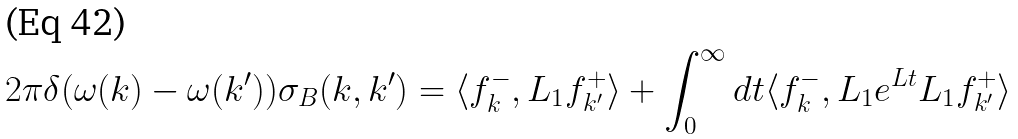<formula> <loc_0><loc_0><loc_500><loc_500>2 \pi \delta ( \omega ( k ) - \omega ( k ^ { \prime } ) ) \sigma _ { B } ( k , k ^ { \prime } ) = \langle f ^ { - } _ { k } , L _ { 1 } f ^ { + } _ { k ^ { \prime } } \rangle + \int ^ { \infty } _ { 0 } d t \langle f ^ { - } _ { k } , L _ { 1 } e ^ { L t } L _ { 1 } f ^ { + } _ { k ^ { \prime } } \rangle</formula> 